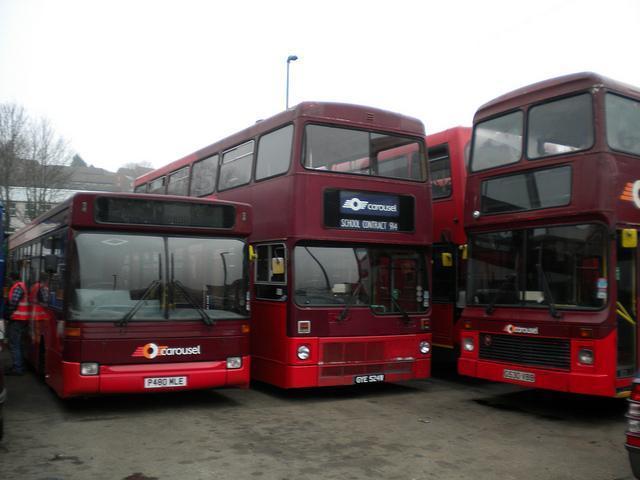How many versions of buses are in this picture?
Give a very brief answer. 2. How many buses are there?
Give a very brief answer. 4. How many clocks are on the building?
Give a very brief answer. 0. 